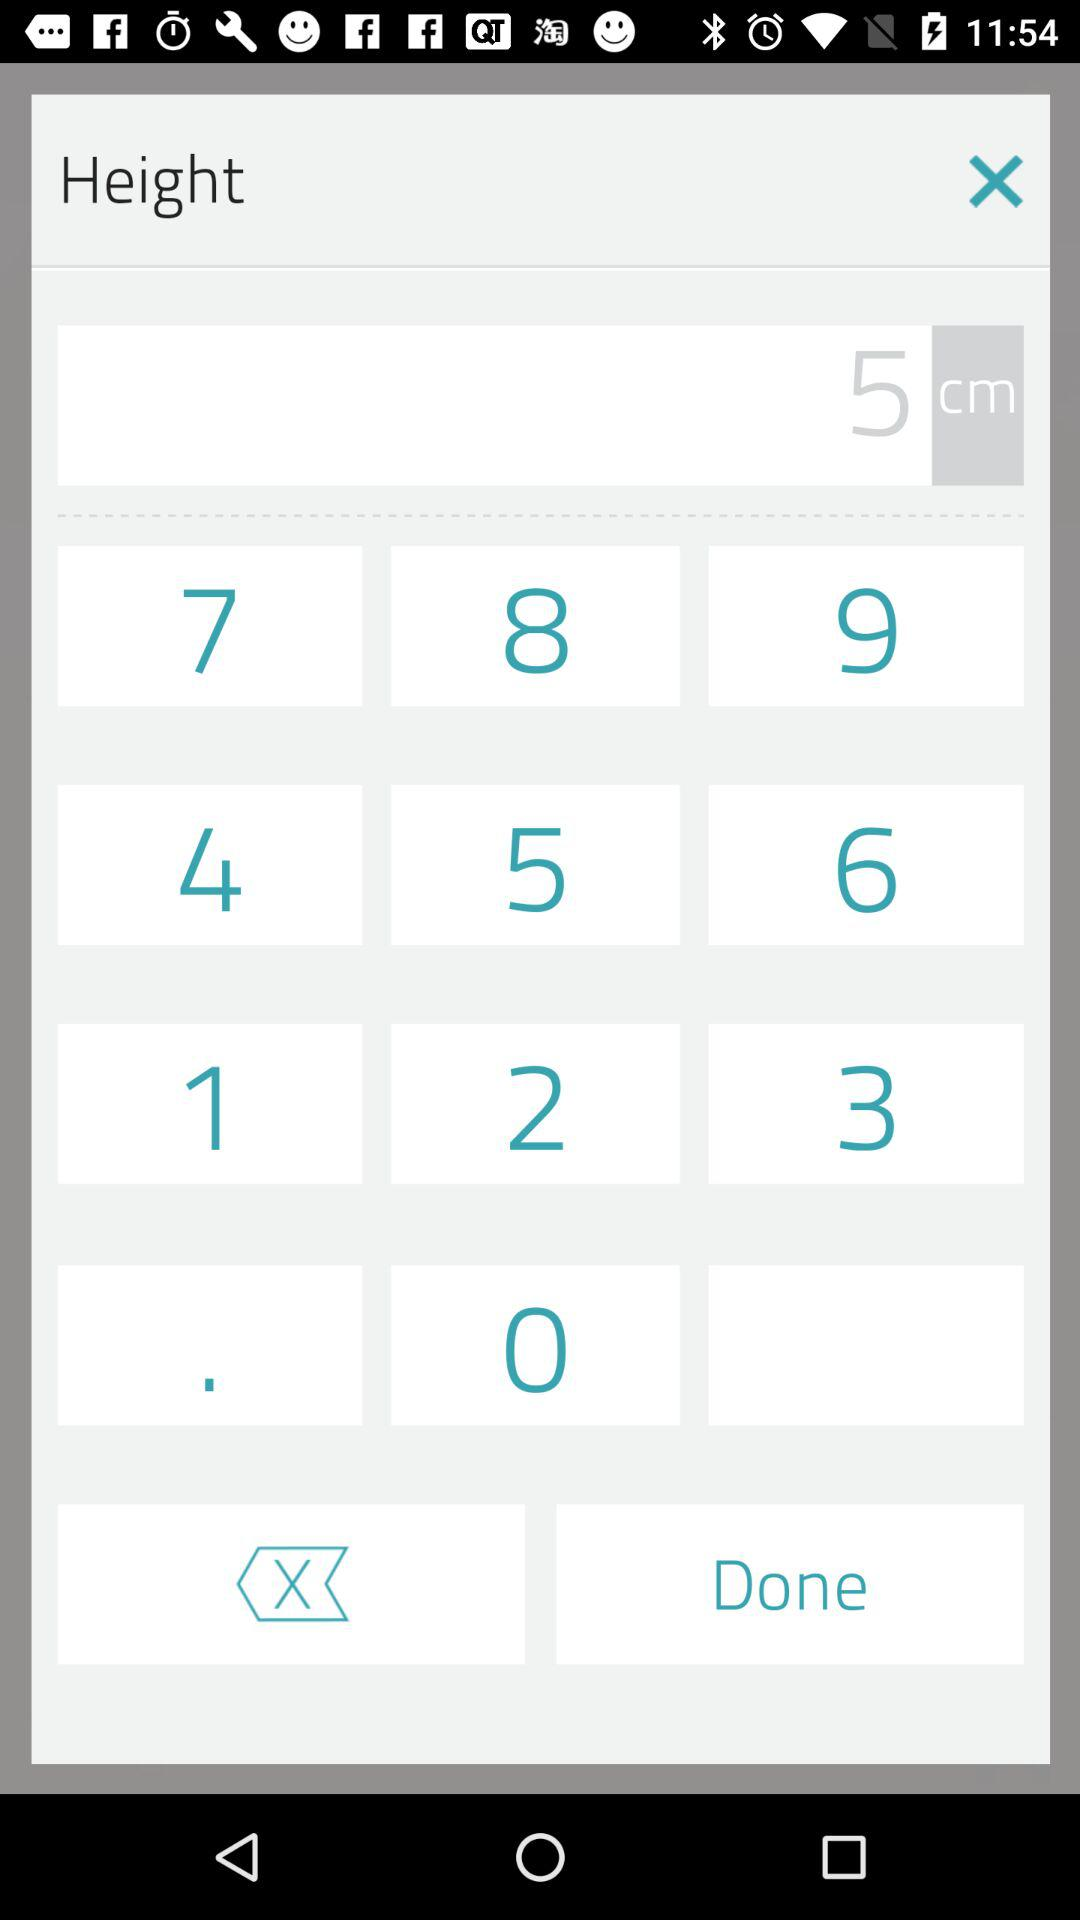Which text is entered in the input field? The text entered in the input field is 5. 